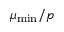<formula> <loc_0><loc_0><loc_500><loc_500>\mu _ { \min } / p</formula> 